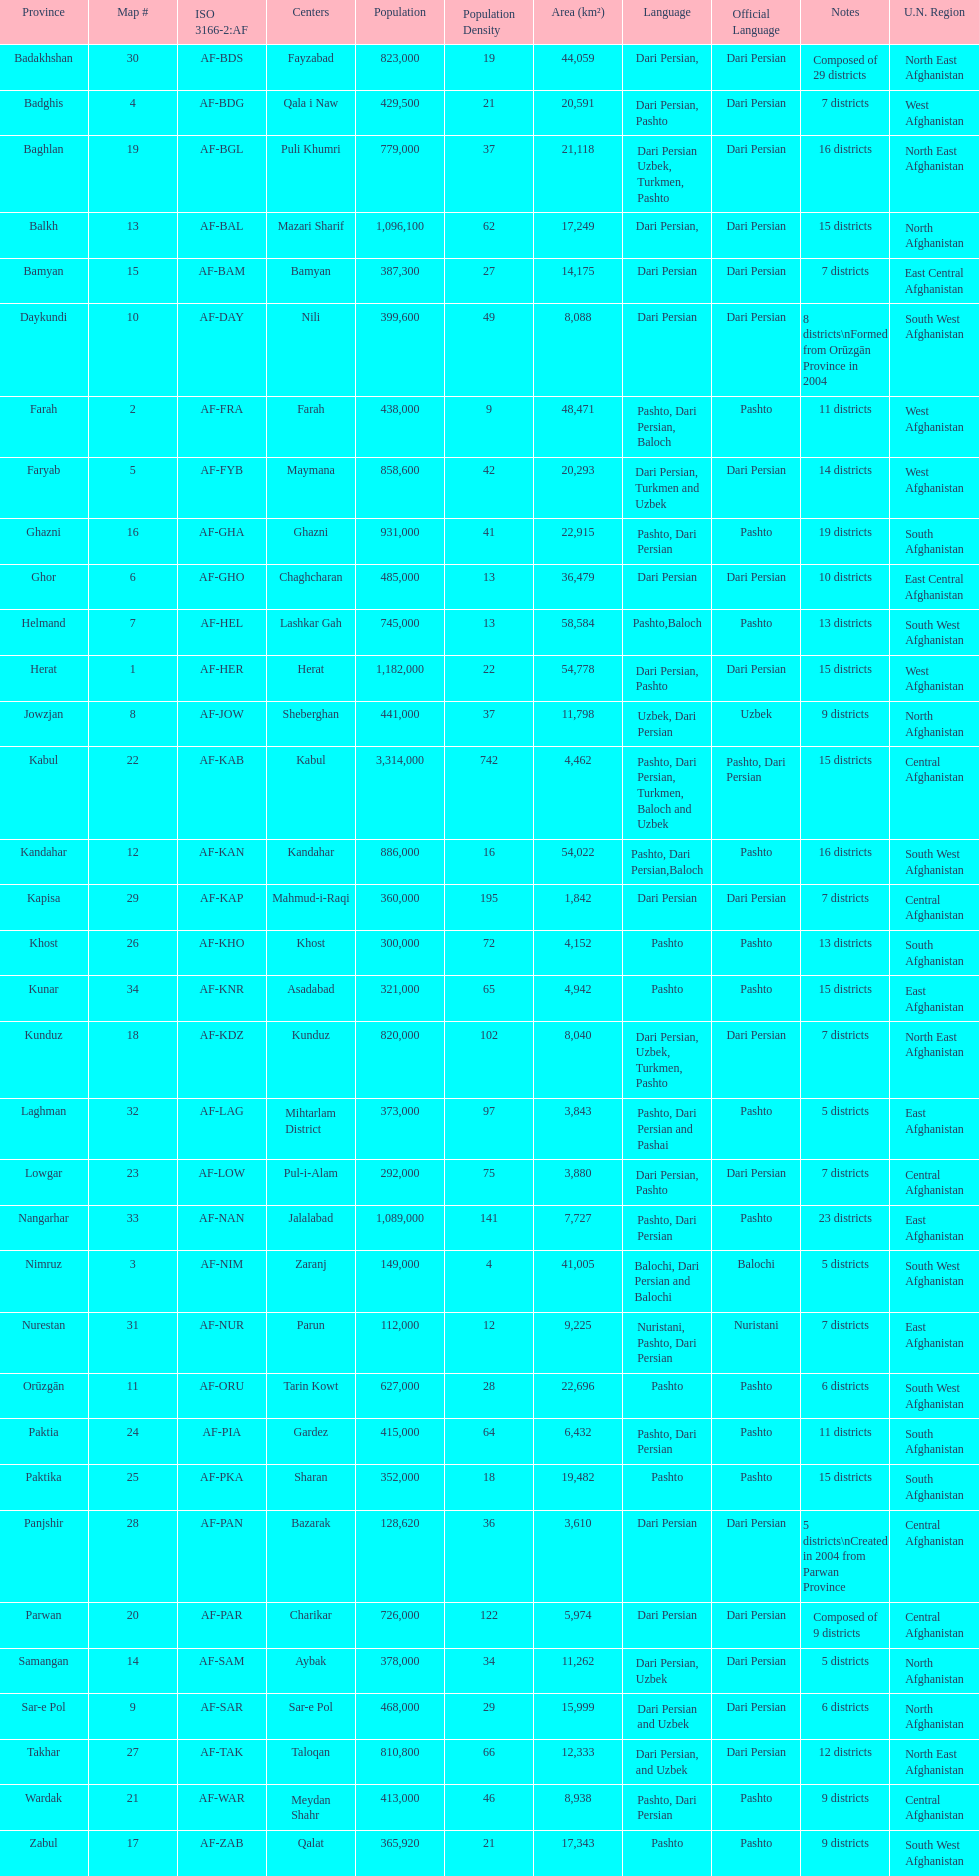Does ghor or farah have more districts? Farah. Would you mind parsing the complete table? {'header': ['Province', 'Map #', 'ISO 3166-2:AF', 'Centers', 'Population', 'Population Density', 'Area (km²)', 'Language', 'Official Language', 'Notes', 'U.N. Region'], 'rows': [['Badakhshan', '30', 'AF-BDS', 'Fayzabad', '823,000', '19', '44,059', 'Dari Persian,', 'Dari Persian', 'Composed of 29 districts', 'North East Afghanistan'], ['Badghis', '4', 'AF-BDG', 'Qala i Naw', '429,500', '21', '20,591', 'Dari Persian, Pashto', 'Dari Persian', '7 districts', 'West Afghanistan'], ['Baghlan', '19', 'AF-BGL', 'Puli Khumri', '779,000', '37', '21,118', 'Dari Persian Uzbek, Turkmen, Pashto', 'Dari Persian', '16 districts', 'North East Afghanistan'], ['Balkh', '13', 'AF-BAL', 'Mazari Sharif', '1,096,100', '62', '17,249', 'Dari Persian,', 'Dari Persian', '15 districts', 'North Afghanistan'], ['Bamyan', '15', 'AF-BAM', 'Bamyan', '387,300', '27', '14,175', 'Dari Persian', 'Dari Persian', '7 districts', 'East Central Afghanistan'], ['Daykundi', '10', 'AF-DAY', 'Nili', '399,600', '49', '8,088', 'Dari Persian', 'Dari Persian', '8 districts\\nFormed from Orūzgān Province in 2004', 'South West Afghanistan'], ['Farah', '2', 'AF-FRA', 'Farah', '438,000', '9', '48,471', 'Pashto, Dari Persian, Baloch', 'Pashto', '11 districts', 'West Afghanistan'], ['Faryab', '5', 'AF-FYB', 'Maymana', '858,600', '42', '20,293', 'Dari Persian, Turkmen and Uzbek', 'Dari Persian', '14 districts', 'West Afghanistan'], ['Ghazni', '16', 'AF-GHA', 'Ghazni', '931,000', '41', '22,915', 'Pashto, Dari Persian', 'Pashto', '19 districts', 'South Afghanistan'], ['Ghor', '6', 'AF-GHO', 'Chaghcharan', '485,000', '13', '36,479', 'Dari Persian', 'Dari Persian', '10 districts', 'East Central Afghanistan'], ['Helmand', '7', 'AF-HEL', 'Lashkar Gah', '745,000', '13', '58,584', 'Pashto,Baloch', 'Pashto', '13 districts', 'South West Afghanistan'], ['Herat', '1', 'AF-HER', 'Herat', '1,182,000', '22', '54,778', 'Dari Persian, Pashto', 'Dari Persian', '15 districts', 'West Afghanistan'], ['Jowzjan', '8', 'AF-JOW', 'Sheberghan', '441,000', '37', '11,798', 'Uzbek, Dari Persian', 'Uzbek', '9 districts', 'North Afghanistan'], ['Kabul', '22', 'AF-KAB', 'Kabul', '3,314,000', '742', '4,462', 'Pashto, Dari Persian, Turkmen, Baloch and Uzbek', 'Pashto, Dari Persian', '15 districts', 'Central Afghanistan'], ['Kandahar', '12', 'AF-KAN', 'Kandahar', '886,000', '16', '54,022', 'Pashto, Dari Persian,Baloch', 'Pashto', '16 districts', 'South West Afghanistan'], ['Kapisa', '29', 'AF-KAP', 'Mahmud-i-Raqi', '360,000', '195', '1,842', 'Dari Persian', 'Dari Persian', '7 districts', 'Central Afghanistan'], ['Khost', '26', 'AF-KHO', 'Khost', '300,000', '72', '4,152', 'Pashto', 'Pashto', '13 districts', 'South Afghanistan'], ['Kunar', '34', 'AF-KNR', 'Asadabad', '321,000', '65', '4,942', 'Pashto', 'Pashto', '15 districts', 'East Afghanistan'], ['Kunduz', '18', 'AF-KDZ', 'Kunduz', '820,000', '102', '8,040', 'Dari Persian, Uzbek, Turkmen, Pashto', 'Dari Persian', '7 districts', 'North East Afghanistan'], ['Laghman', '32', 'AF-LAG', 'Mihtarlam District', '373,000', '97', '3,843', 'Pashto, Dari Persian and Pashai', 'Pashto', '5 districts', 'East Afghanistan'], ['Lowgar', '23', 'AF-LOW', 'Pul-i-Alam', '292,000', '75', '3,880', 'Dari Persian, Pashto', 'Dari Persian', '7 districts', 'Central Afghanistan'], ['Nangarhar', '33', 'AF-NAN', 'Jalalabad', '1,089,000', '141', '7,727', 'Pashto, Dari Persian', 'Pashto', '23 districts', 'East Afghanistan'], ['Nimruz', '3', 'AF-NIM', 'Zaranj', '149,000', '4', '41,005', 'Balochi, Dari Persian and Balochi', 'Balochi', '5 districts', 'South West Afghanistan'], ['Nurestan', '31', 'AF-NUR', 'Parun', '112,000', '12', '9,225', 'Nuristani, Pashto, Dari Persian', 'Nuristani', '7 districts', 'East Afghanistan'], ['Orūzgān', '11', 'AF-ORU', 'Tarin Kowt', '627,000', '28', '22,696', 'Pashto', 'Pashto', '6 districts', 'South West Afghanistan'], ['Paktia', '24', 'AF-PIA', 'Gardez', '415,000', '64', '6,432', 'Pashto, Dari Persian', 'Pashto', '11 districts', 'South Afghanistan'], ['Paktika', '25', 'AF-PKA', 'Sharan', '352,000', '18', '19,482', 'Pashto', 'Pashto', '15 districts', 'South Afghanistan'], ['Panjshir', '28', 'AF-PAN', 'Bazarak', '128,620', '36', '3,610', 'Dari Persian', 'Dari Persian', '5 districts\\nCreated in 2004 from Parwan Province', 'Central Afghanistan'], ['Parwan', '20', 'AF-PAR', 'Charikar', '726,000', '122', '5,974', 'Dari Persian', 'Dari Persian', 'Composed of 9 districts', 'Central Afghanistan'], ['Samangan', '14', 'AF-SAM', 'Aybak', '378,000', '34', '11,262', 'Dari Persian, Uzbek', 'Dari Persian', '5 districts', 'North Afghanistan'], ['Sar-e Pol', '9', 'AF-SAR', 'Sar-e Pol', '468,000', '29', '15,999', 'Dari Persian and Uzbek', 'Dari Persian', '6 districts', 'North Afghanistan'], ['Takhar', '27', 'AF-TAK', 'Taloqan', '810,800', '66', '12,333', 'Dari Persian, and Uzbek', 'Dari Persian', '12 districts', 'North East Afghanistan'], ['Wardak', '21', 'AF-WAR', 'Meydan Shahr', '413,000', '46', '8,938', 'Pashto, Dari Persian', 'Pashto', '9 districts', 'Central Afghanistan'], ['Zabul', '17', 'AF-ZAB', 'Qalat', '365,920', '21', '17,343', 'Pashto', 'Pashto', '9 districts', 'South West Afghanistan']]} 